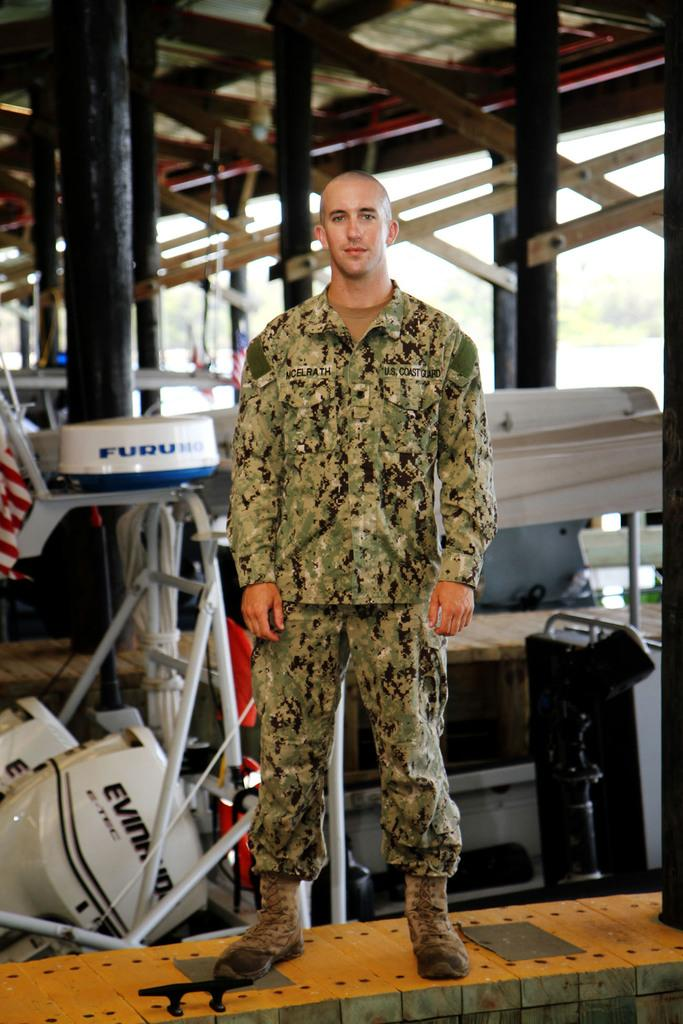What is the main subject of the image? There is a man standing in the image. Can you describe the background of the image? There is a shed in the background of the image. How many ghosts can be seen interacting with the man in the image? There are no ghosts present in the image; it only features a man standing and a shed in the background. What type of park is visible in the image? There is no park visible in the image; it only features a man standing and a shed in the background. 